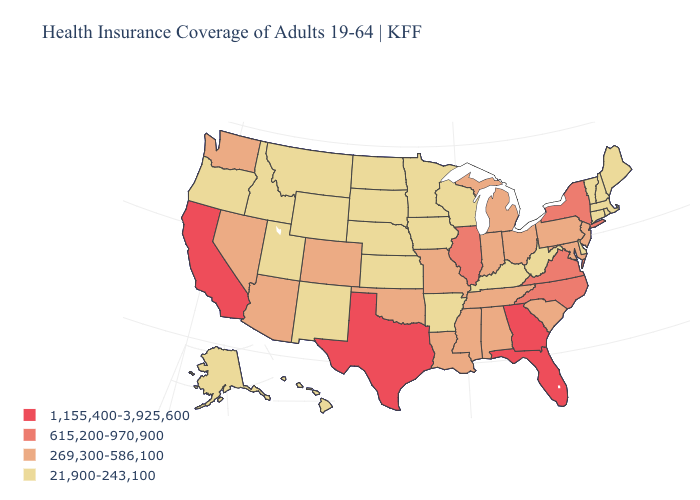What is the lowest value in states that border Oregon?
Be succinct. 21,900-243,100. Is the legend a continuous bar?
Answer briefly. No. What is the highest value in states that border Mississippi?
Give a very brief answer. 269,300-586,100. Does Maine have a lower value than Iowa?
Be succinct. No. Name the states that have a value in the range 269,300-586,100?
Give a very brief answer. Alabama, Arizona, Colorado, Indiana, Louisiana, Maryland, Michigan, Mississippi, Missouri, Nevada, New Jersey, Ohio, Oklahoma, Pennsylvania, South Carolina, Tennessee, Washington. What is the value of Pennsylvania?
Give a very brief answer. 269,300-586,100. Name the states that have a value in the range 269,300-586,100?
Write a very short answer. Alabama, Arizona, Colorado, Indiana, Louisiana, Maryland, Michigan, Mississippi, Missouri, Nevada, New Jersey, Ohio, Oklahoma, Pennsylvania, South Carolina, Tennessee, Washington. What is the value of North Carolina?
Give a very brief answer. 615,200-970,900. What is the highest value in the MidWest ?
Write a very short answer. 615,200-970,900. What is the value of Connecticut?
Short answer required. 21,900-243,100. Name the states that have a value in the range 615,200-970,900?
Keep it brief. Illinois, New York, North Carolina, Virginia. How many symbols are there in the legend?
Concise answer only. 4. Does Georgia have the highest value in the South?
Concise answer only. Yes. Does the first symbol in the legend represent the smallest category?
Answer briefly. No. Does Georgia have the highest value in the USA?
Keep it brief. Yes. 